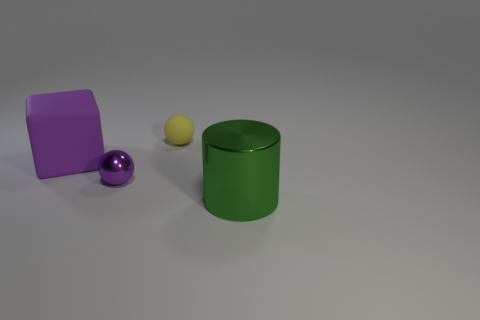Does the tiny metallic object have the same color as the large object that is to the right of the small rubber thing?
Your answer should be very brief. No. There is a sphere in front of the rubber thing that is to the right of the metal ball; what is its color?
Your answer should be compact. Purple. Is there a yellow matte object that is in front of the matte object that is in front of the tiny yellow matte thing to the right of the tiny purple ball?
Make the answer very short. No. There is a block that is made of the same material as the yellow ball; what is its color?
Offer a terse response. Purple. How many large purple cubes have the same material as the purple sphere?
Your response must be concise. 0. Are the large green cylinder and the purple object that is in front of the large purple object made of the same material?
Give a very brief answer. Yes. How many objects are objects that are left of the green cylinder or small yellow balls?
Offer a terse response. 3. There is a object that is behind the purple object to the left of the purple thing in front of the big purple matte thing; what is its size?
Keep it short and to the point. Small. What material is the ball that is the same color as the big rubber thing?
Make the answer very short. Metal. Is there anything else that is the same shape as the big green thing?
Provide a short and direct response. No. 